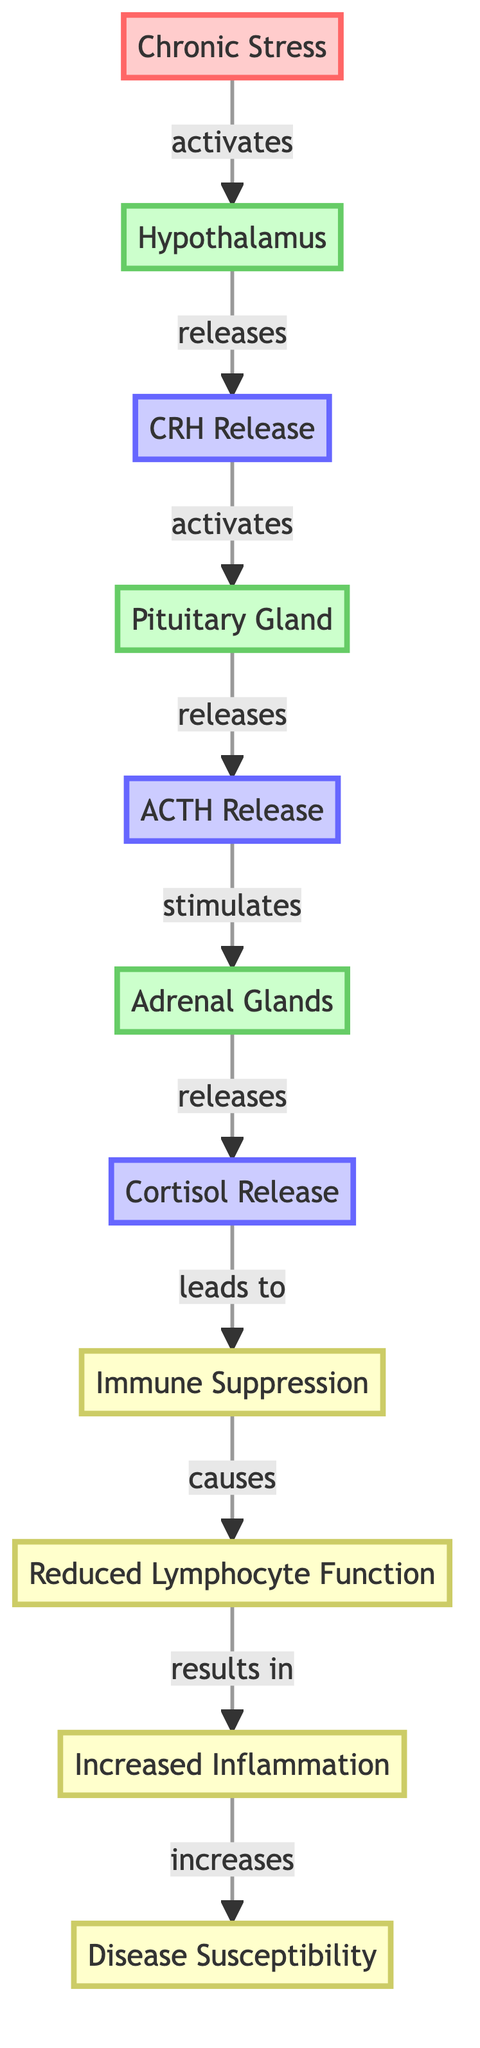What triggers the release of CRH? The diagram indicates that Chronic Stress activates the Hypothalamus, which then releases CRH. Thus, the trigger is Chronic Stress.
Answer: Chronic Stress How many glands are involved in the response? The flowchart includes three glands: the Hypothalamus, Pituitary Gland, and Adrenal Glands. Hence, the number is three.
Answer: 3 What is the final outcome of increased inflammation? The diagram shows that Increased Inflammation leads to Disease Susceptibility. Therefore, the final outcome is Disease Susceptibility.
Answer: Disease Susceptibility Which hormone is released after the Pituitary Gland? According to the diagram, after the Pituitary Gland releases ACTH, it stimulates the Adrenal Glands. Thus, the hormone released after is ACTH.
Answer: ACTH What happens as a result of Cortisol release? The diagram illustrates that Cortisol release leads to Immune Suppression. This is a direct consequence of Cortisol release.
Answer: Immune Suppression What relationship exists between Reduced Lymphocyte Function and Increased Inflammation? The diagram indicates that Reduced Lymphocyte Function causes Increased Inflammation, showing a direct relationship where one leads to the other.
Answer: causes What activates the Pituitary Gland? The flowchart shows that CRH Release activates the Pituitary Gland, which implies that CRH is needed to trigger its activity.
Answer: CRH Release What is the impact of Chronic Stress on the immune system? The flowchart details that Chronic Stress leads to Immune Suppression and Reduced Lymphocyte Function, illustrating its negative impact on the immune system.
Answer: Immune Suppression 